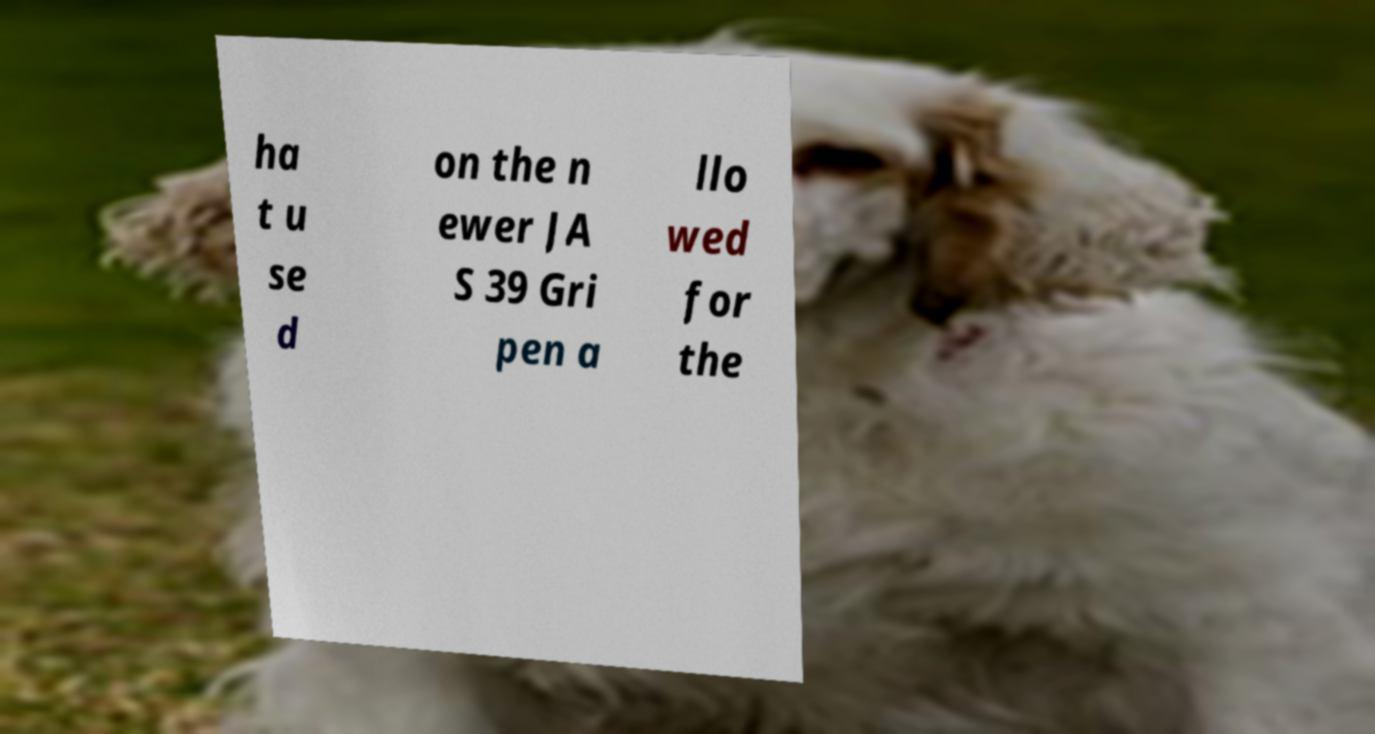For documentation purposes, I need the text within this image transcribed. Could you provide that? ha t u se d on the n ewer JA S 39 Gri pen a llo wed for the 